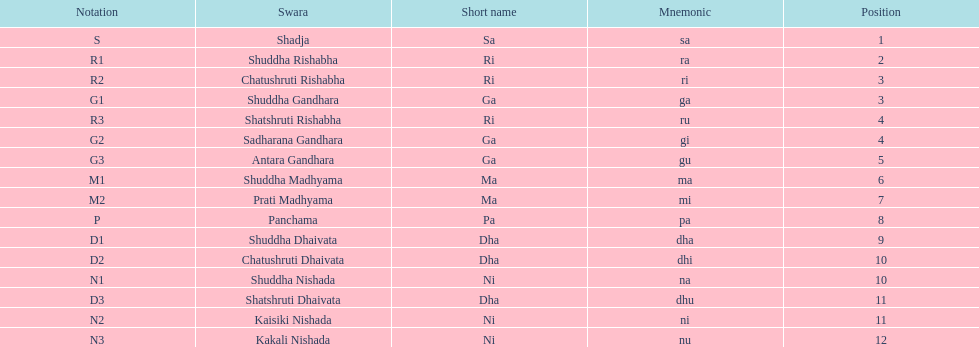Find the 9th position swara. what is its short name? Dha. 